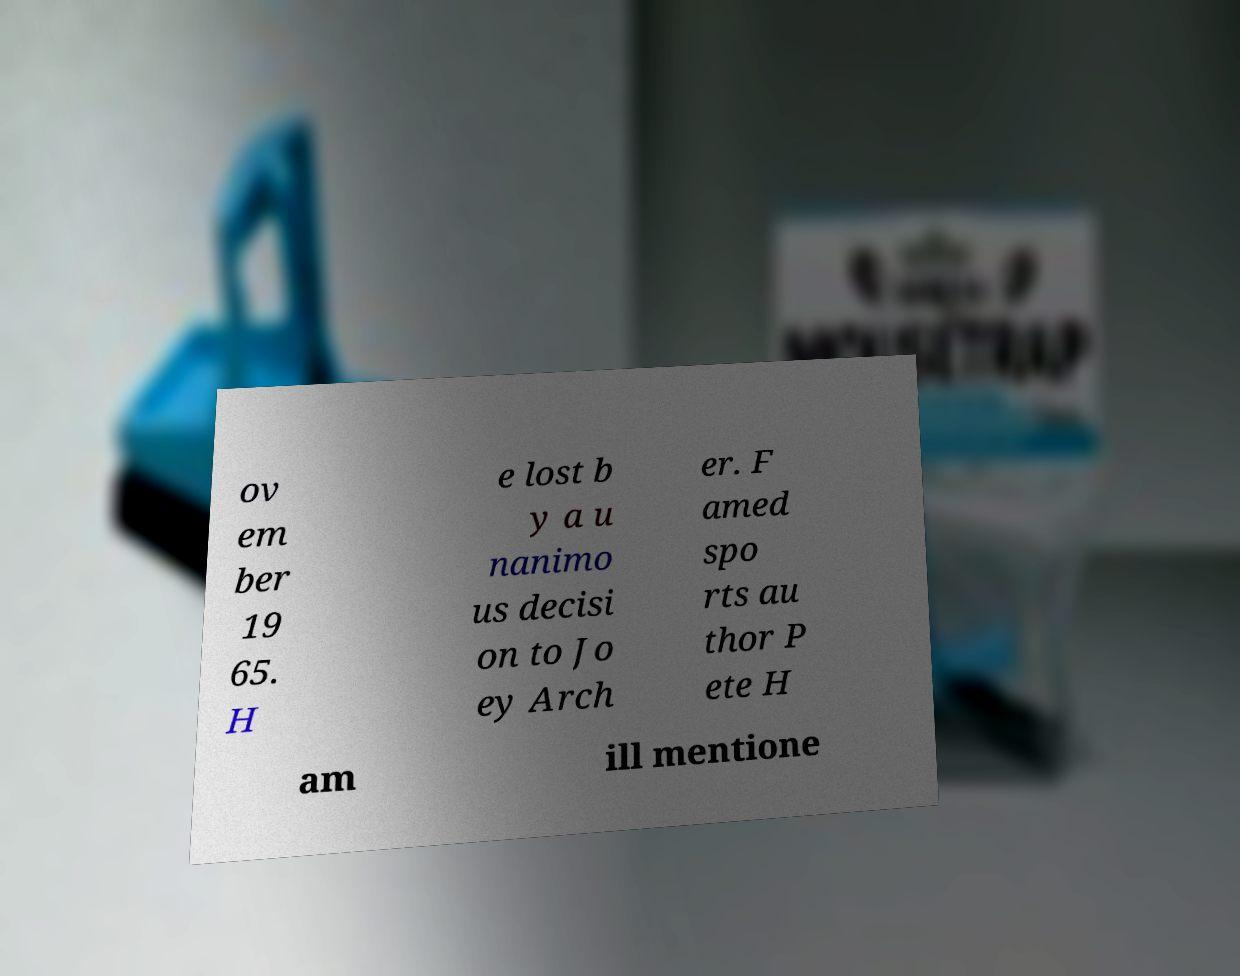Can you accurately transcribe the text from the provided image for me? ov em ber 19 65. H e lost b y a u nanimo us decisi on to Jo ey Arch er. F amed spo rts au thor P ete H am ill mentione 